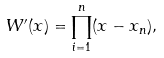<formula> <loc_0><loc_0><loc_500><loc_500>W ^ { \prime } ( x ) = \prod _ { i = 1 } ^ { n } ( x - x _ { n } ) ,</formula> 